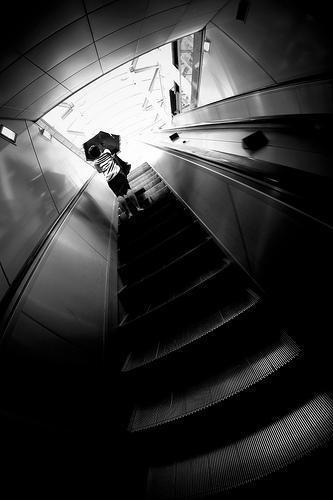How many people?
Give a very brief answer. 1. 